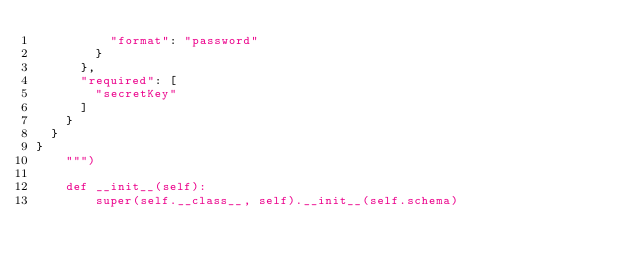Convert code to text. <code><loc_0><loc_0><loc_500><loc_500><_Python_>          "format": "password"
        }
      },
      "required": [
        "secretKey"
      ]
    }
  }
}
    """)

    def __init__(self):
        super(self.__class__, self).__init__(self.schema)
</code> 